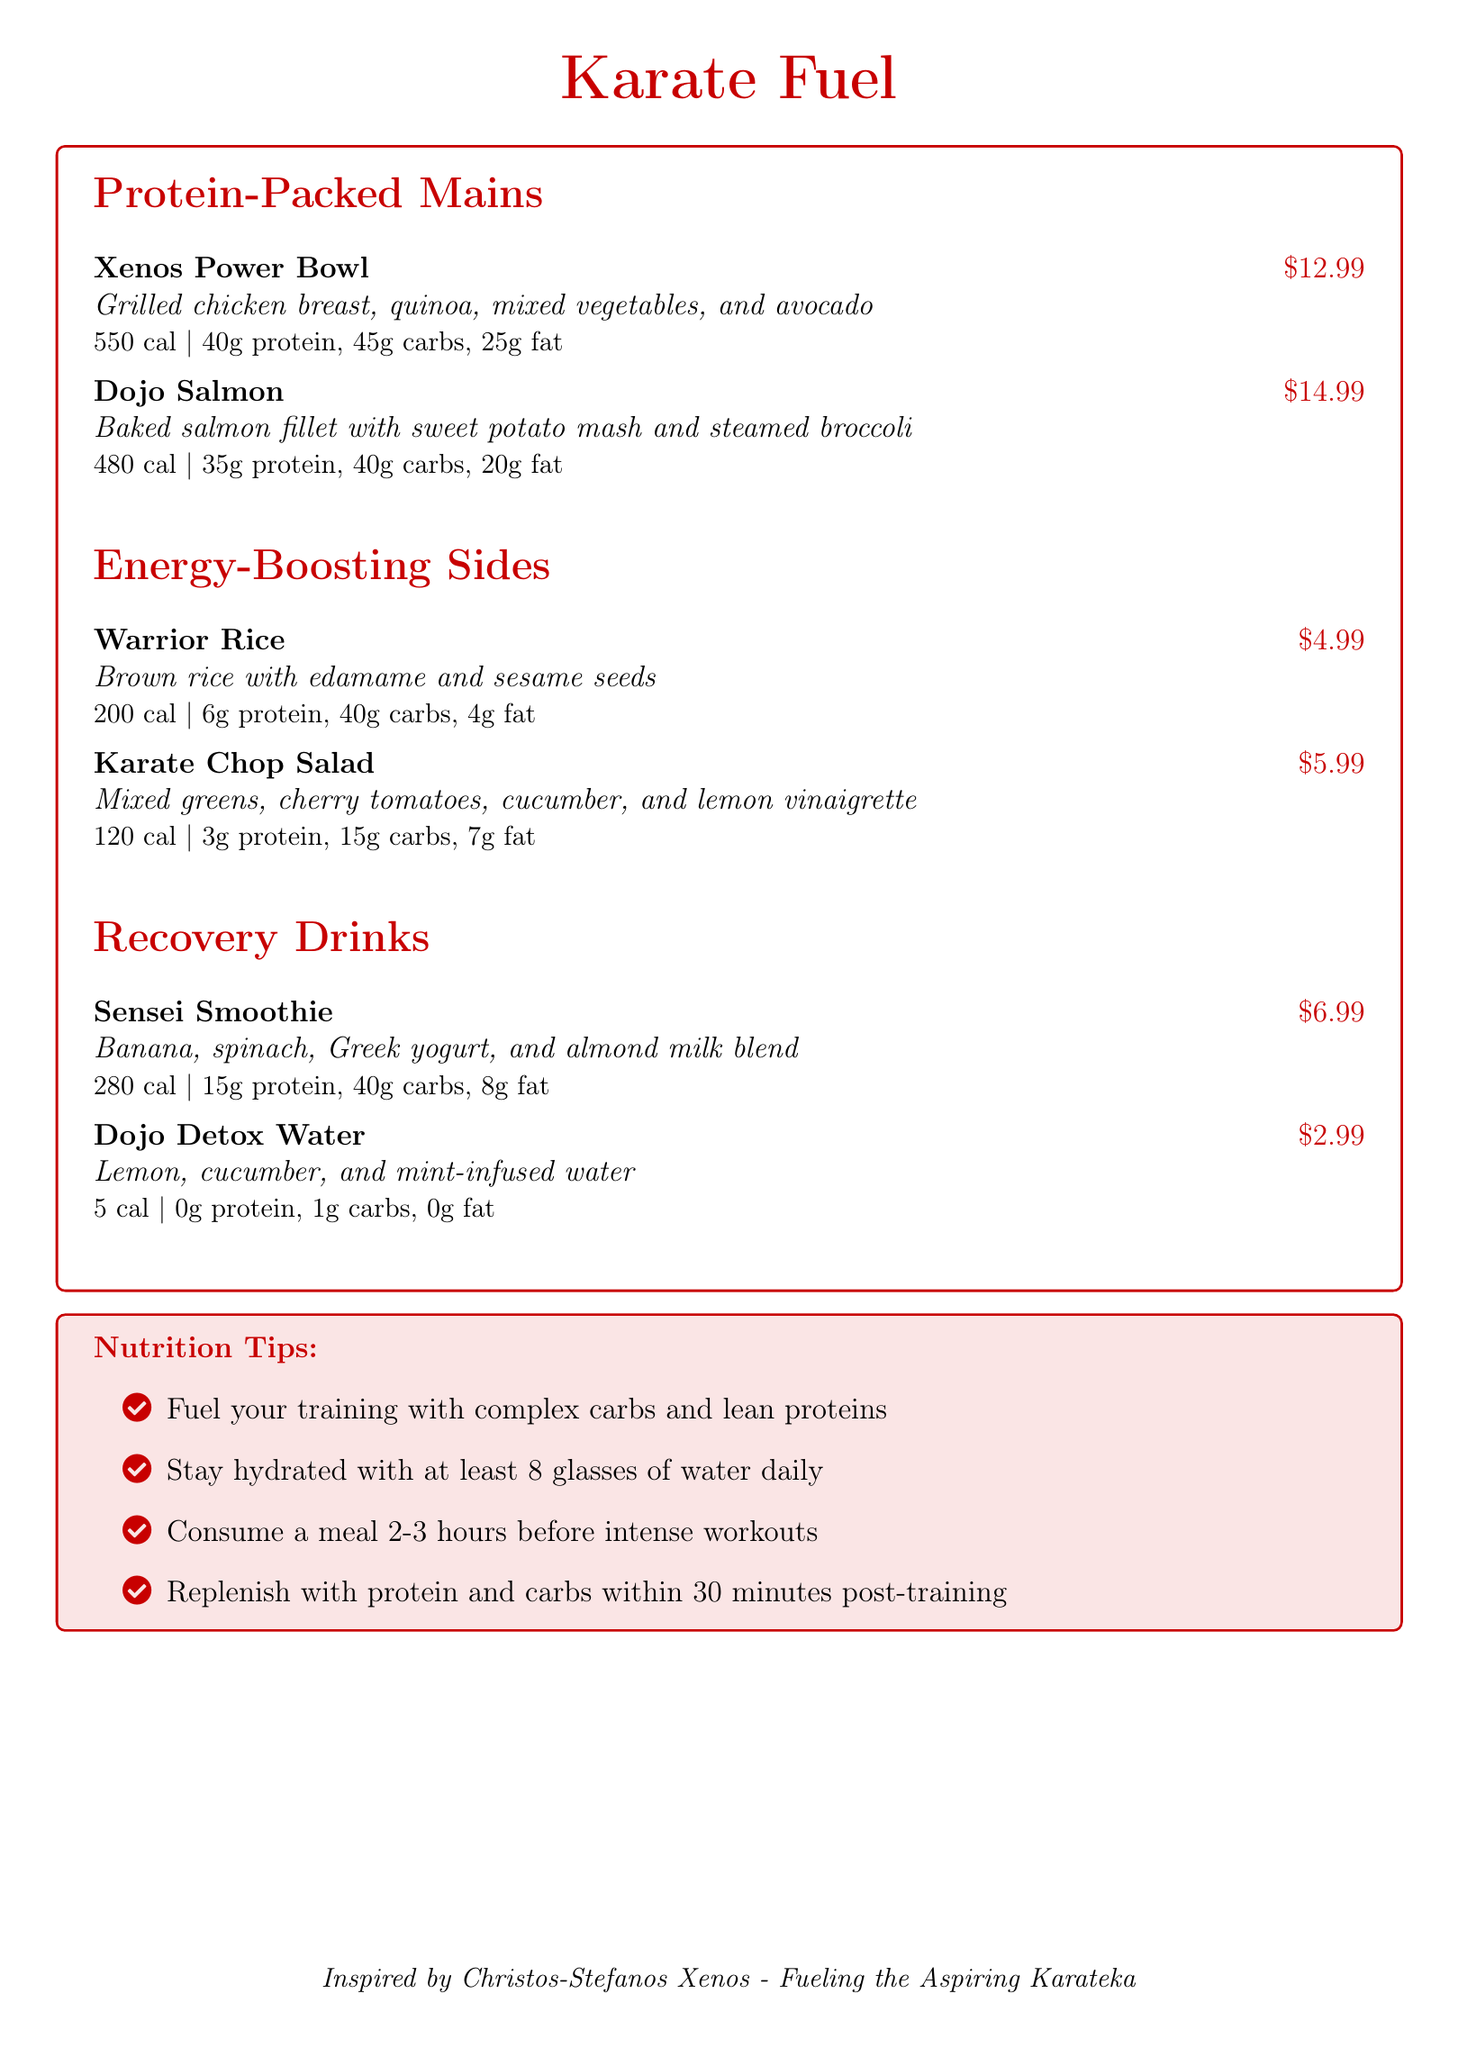what is the price of the Xenos Power Bowl? The price is listed next to the dish in the menu.
Answer: $12.99 how many grams of protein are in the Dojo Salmon? The protein content is provided in the macronutrient breakdown for each dish.
Answer: 35g what is the calorie count of the Warrior Rice? The calorie count is specified under the description of each menu item.
Answer: 200 cal what ingredients are in the Sensei Smoothie? The ingredients are listed in the description of the drink.
Answer: Banana, spinach, Greek yogurt, and almond milk how much does the Karate Chop Salad cost? The price is mentioned for each side dish in the menu.
Answer: $5.99 what macronutrients are recommended to fuel your training? The nutrition tips suggest specific nutrients that are beneficial for training.
Answer: Complex carbs and lean proteins how many calories are in the Dojo Detox Water? The calorie count is provided for each drink in the menu section.
Answer: 5 cal what is the total fat content in the Xenos Power Bowl? The total fat is included in the macronutrient breakdown for the dish.
Answer: 25g which item on the menu has the highest calorie count? The calorie counts are visible for each item allowing for comparison.
Answer: Xenos Power Bowl (550 cal) 